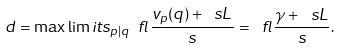<formula> <loc_0><loc_0><loc_500><loc_500>d = \max \lim i t s _ { p | q } \ f l { \frac { v _ { p } ( q ) + \ s L } { s } } = \ f l { \frac { \gamma + \ s L } { s } } .</formula> 